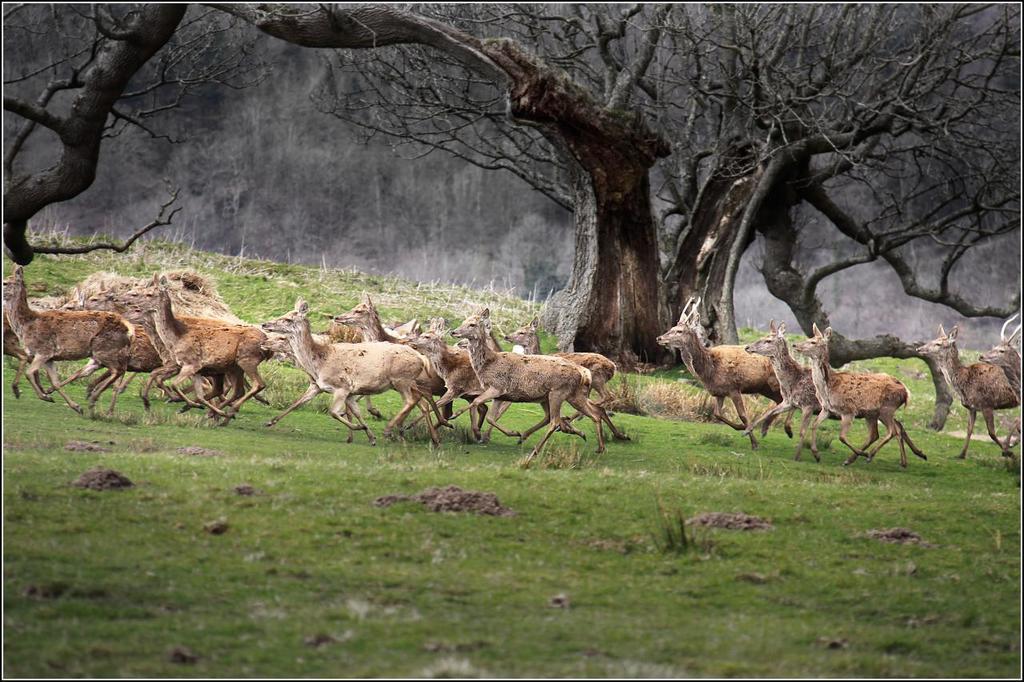Describe this image in one or two sentences. In the image we can see there are deers standing on the ground and the ground is covered with grass. Behind there are lot of trees. 